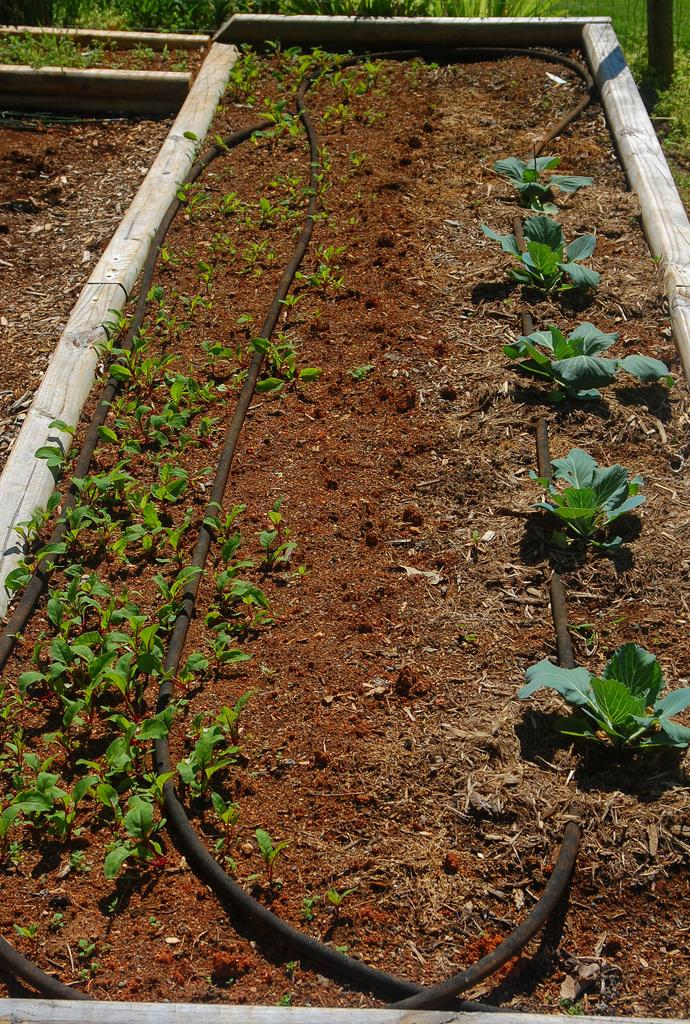What type of surface is visible in the image? There is a soil surface in the image. What is growing on the soil surface in the image? There are plants in the soil in the image. Can you tell me what type of doctor is examining the plants in the image? There is no doctor present in the image; it only features a soil surface with plants growing on it. What type of knot can be seen tied around the plants in the image? There is no knot present around the plants in the image; it only features a soil surface with plants growing on it. 